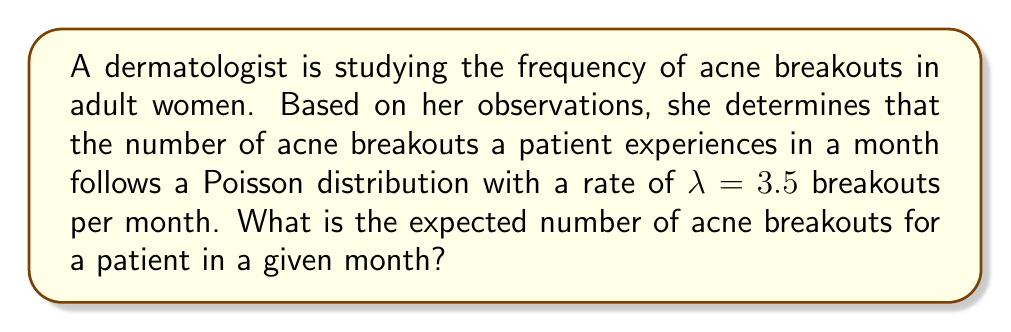Show me your answer to this math problem. To solve this problem, we need to understand the properties of the Poisson distribution:

1. The Poisson distribution is used to model the number of events occurring in a fixed interval of time or space, given a known average rate.

2. For a Poisson distribution, the expected value (mean) is equal to the rate parameter $\lambda$.

3. The probability mass function of a Poisson distribution is given by:

   $$P(X = k) = \frac{e^{-\lambda}\lambda^k}{k!}$$

   where $k$ is the number of events and $\lambda$ is the rate parameter.

In this case:
- The random variable $X$ represents the number of acne breakouts in a month.
- The rate parameter $\lambda = 3.5$ breakouts per month.

For a Poisson distribution, the expected value $E(X)$ is equal to $\lambda$. Therefore:

$$E(X) = \lambda = 3.5$$

This means that, on average, a patient is expected to experience 3.5 acne breakouts per month.
Answer: The expected number of acne breakouts for a patient in a given month is 3.5. 